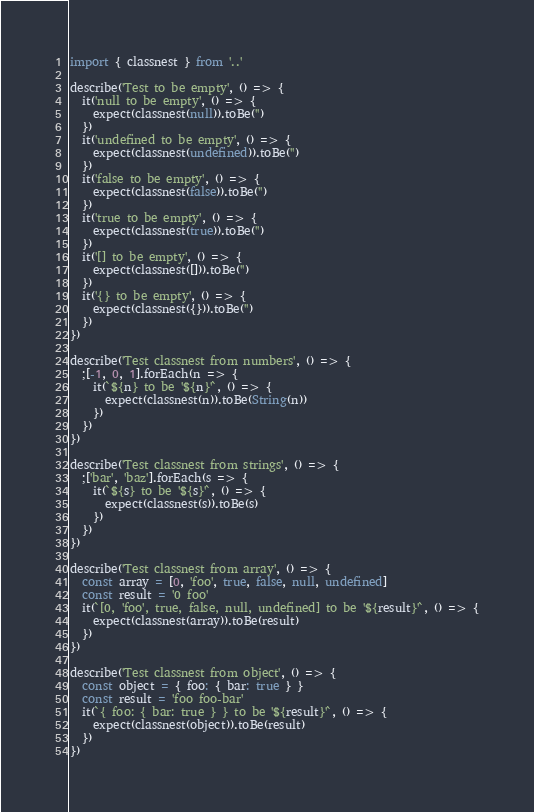Convert code to text. <code><loc_0><loc_0><loc_500><loc_500><_TypeScript_>import { classnest } from '..'

describe('Test to be empty', () => {
  it('null to be empty', () => {
    expect(classnest(null)).toBe('')
  })
  it('undefined to be empty', () => {
    expect(classnest(undefined)).toBe('')
  })
  it('false to be empty', () => {
    expect(classnest(false)).toBe('')
  })
  it('true to be empty', () => {
    expect(classnest(true)).toBe('')
  })
  it('[] to be empty', () => {
    expect(classnest([])).toBe('')
  })
  it('{} to be empty', () => {
    expect(classnest({})).toBe('')
  })
})

describe('Test classnest from numbers', () => {
  ;[-1, 0, 1].forEach(n => {
    it(`${n} to be '${n}'`, () => {
      expect(classnest(n)).toBe(String(n))
    })
  })
})

describe('Test classnest from strings', () => {
  ;['bar', 'baz'].forEach(s => {
    it(`${s} to be '${s}'`, () => {
      expect(classnest(s)).toBe(s)
    })
  })
})

describe('Test classnest from array', () => {
  const array = [0, 'foo', true, false, null, undefined]
  const result = '0 foo'
  it(`[0, 'foo', true, false, null, undefined] to be '${result}'`, () => {
    expect(classnest(array)).toBe(result)
  })
})

describe('Test classnest from object', () => {
  const object = { foo: { bar: true } }
  const result = 'foo foo-bar'
  it(`{ foo: { bar: true } } to be '${result}'`, () => {
    expect(classnest(object)).toBe(result)
  })
})
</code> 